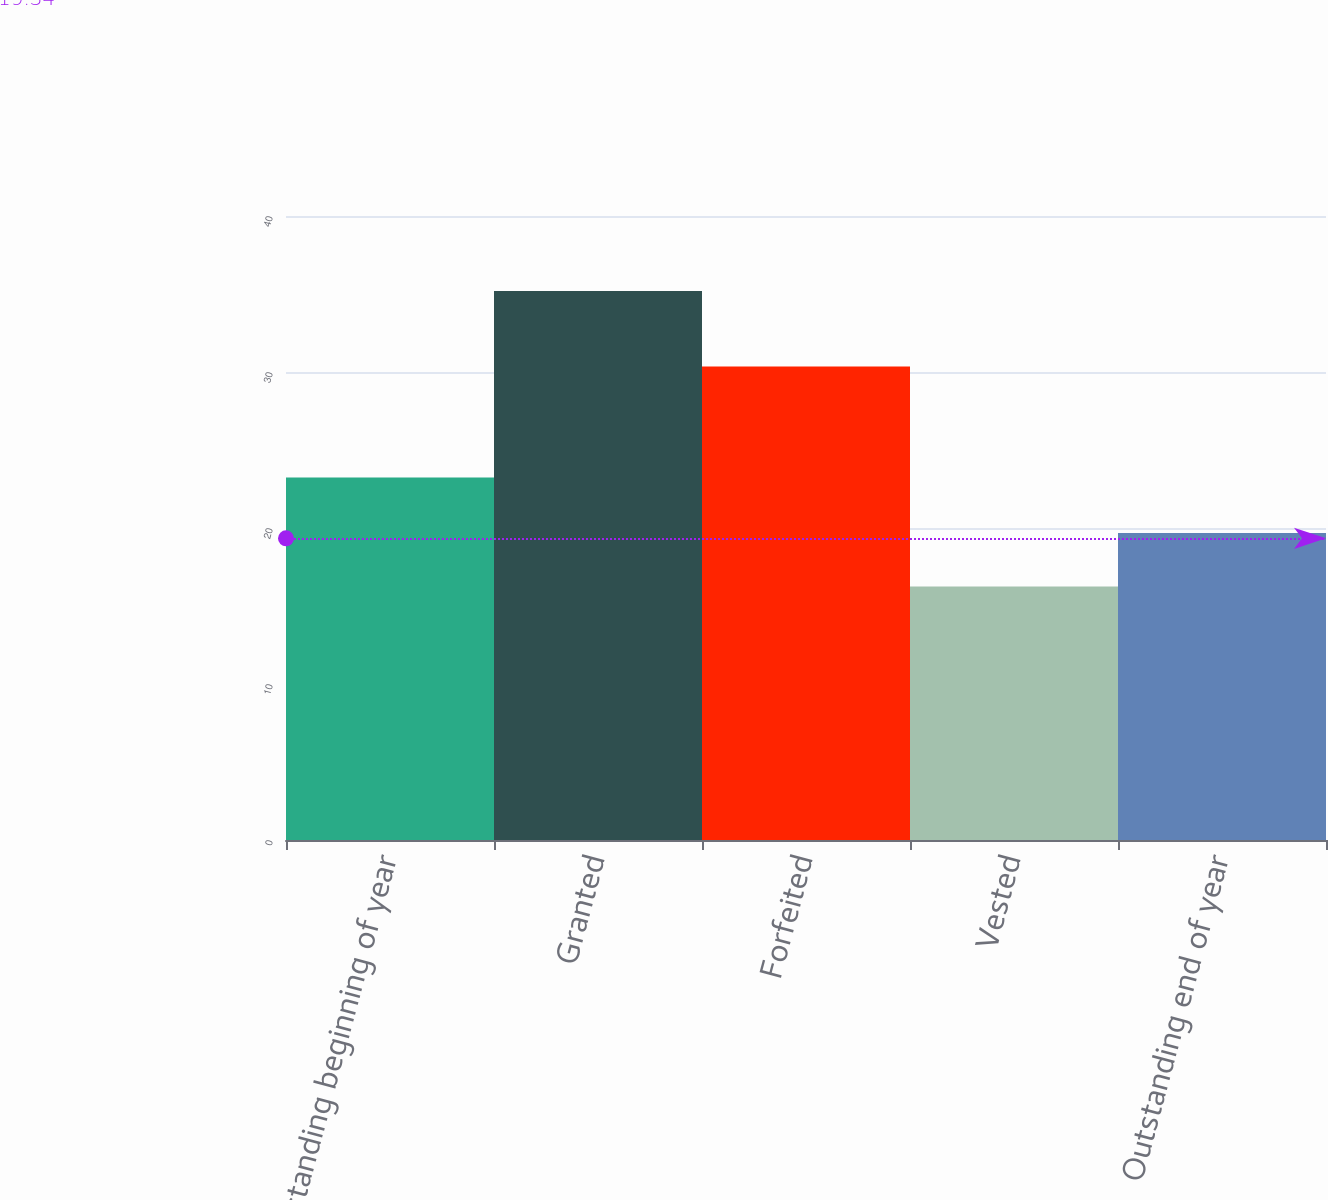Convert chart. <chart><loc_0><loc_0><loc_500><loc_500><bar_chart><fcel>Outstanding beginning of year<fcel>Granted<fcel>Forfeited<fcel>Vested<fcel>Outstanding end of year<nl><fcel>23.23<fcel>35.2<fcel>30.35<fcel>16.25<fcel>19.68<nl></chart> 